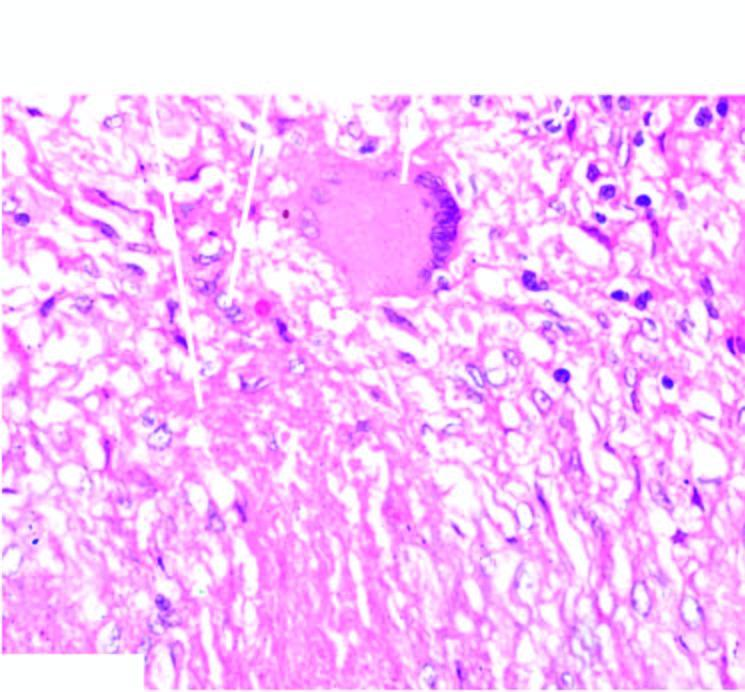what does periphery show?
Answer the question using a single word or phrase. Lymphocytes 